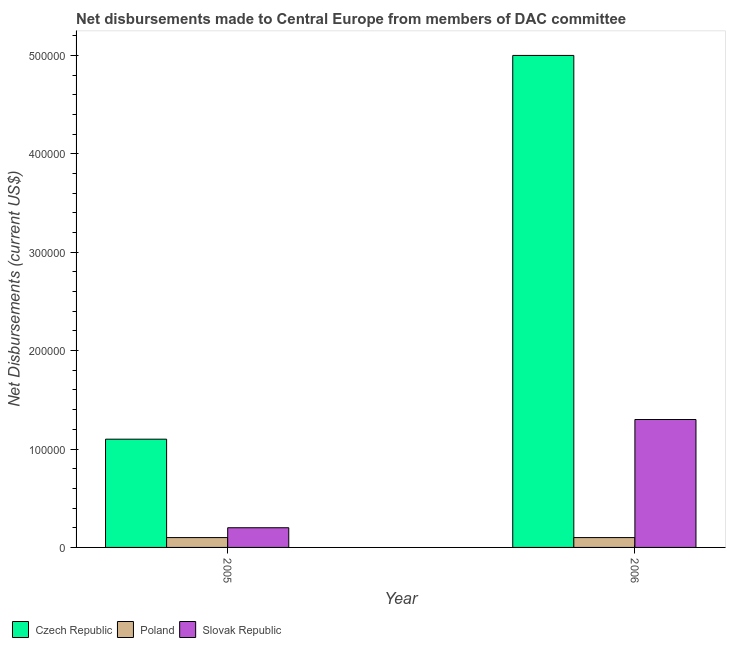How many different coloured bars are there?
Your answer should be compact. 3. How many groups of bars are there?
Provide a succinct answer. 2. How many bars are there on the 1st tick from the right?
Your response must be concise. 3. What is the label of the 2nd group of bars from the left?
Offer a very short reply. 2006. In how many cases, is the number of bars for a given year not equal to the number of legend labels?
Offer a very short reply. 0. What is the net disbursements made by slovak republic in 2005?
Offer a very short reply. 2.00e+04. Across all years, what is the maximum net disbursements made by czech republic?
Provide a succinct answer. 5.00e+05. Across all years, what is the minimum net disbursements made by slovak republic?
Provide a short and direct response. 2.00e+04. In which year was the net disbursements made by slovak republic minimum?
Make the answer very short. 2005. What is the total net disbursements made by poland in the graph?
Make the answer very short. 2.00e+04. What is the difference between the net disbursements made by poland in 2005 and that in 2006?
Provide a succinct answer. 0. What is the difference between the net disbursements made by slovak republic in 2006 and the net disbursements made by czech republic in 2005?
Your response must be concise. 1.10e+05. What is the average net disbursements made by slovak republic per year?
Ensure brevity in your answer.  7.50e+04. In the year 2005, what is the difference between the net disbursements made by poland and net disbursements made by czech republic?
Offer a very short reply. 0. What is the ratio of the net disbursements made by slovak republic in 2005 to that in 2006?
Keep it short and to the point. 0.15. Is the net disbursements made by poland in 2005 less than that in 2006?
Provide a succinct answer. No. What does the 1st bar from the left in 2006 represents?
Provide a short and direct response. Czech Republic. What does the 3rd bar from the right in 2005 represents?
Your answer should be compact. Czech Republic. How many years are there in the graph?
Keep it short and to the point. 2. What is the difference between two consecutive major ticks on the Y-axis?
Give a very brief answer. 1.00e+05. Are the values on the major ticks of Y-axis written in scientific E-notation?
Your answer should be compact. No. Does the graph contain any zero values?
Keep it short and to the point. No. Does the graph contain grids?
Make the answer very short. No. What is the title of the graph?
Keep it short and to the point. Net disbursements made to Central Europe from members of DAC committee. Does "Argument" appear as one of the legend labels in the graph?
Offer a very short reply. No. What is the label or title of the X-axis?
Keep it short and to the point. Year. What is the label or title of the Y-axis?
Your answer should be compact. Net Disbursements (current US$). What is the Net Disbursements (current US$) of Poland in 2005?
Your response must be concise. 10000. What is the Net Disbursements (current US$) in Slovak Republic in 2005?
Your response must be concise. 2.00e+04. What is the Net Disbursements (current US$) in Slovak Republic in 2006?
Offer a very short reply. 1.30e+05. Across all years, what is the maximum Net Disbursements (current US$) of Czech Republic?
Provide a succinct answer. 5.00e+05. Across all years, what is the maximum Net Disbursements (current US$) of Slovak Republic?
Offer a very short reply. 1.30e+05. What is the total Net Disbursements (current US$) in Czech Republic in the graph?
Keep it short and to the point. 6.10e+05. What is the total Net Disbursements (current US$) in Slovak Republic in the graph?
Your answer should be very brief. 1.50e+05. What is the difference between the Net Disbursements (current US$) in Czech Republic in 2005 and that in 2006?
Your response must be concise. -3.90e+05. What is the difference between the Net Disbursements (current US$) in Slovak Republic in 2005 and that in 2006?
Offer a terse response. -1.10e+05. What is the difference between the Net Disbursements (current US$) of Czech Republic in 2005 and the Net Disbursements (current US$) of Poland in 2006?
Give a very brief answer. 1.00e+05. What is the difference between the Net Disbursements (current US$) of Czech Republic in 2005 and the Net Disbursements (current US$) of Slovak Republic in 2006?
Offer a very short reply. -2.00e+04. What is the average Net Disbursements (current US$) in Czech Republic per year?
Your response must be concise. 3.05e+05. What is the average Net Disbursements (current US$) of Poland per year?
Keep it short and to the point. 10000. What is the average Net Disbursements (current US$) of Slovak Republic per year?
Provide a short and direct response. 7.50e+04. In the year 2005, what is the difference between the Net Disbursements (current US$) of Czech Republic and Net Disbursements (current US$) of Poland?
Ensure brevity in your answer.  1.00e+05. In the year 2005, what is the difference between the Net Disbursements (current US$) of Poland and Net Disbursements (current US$) of Slovak Republic?
Your answer should be very brief. -10000. In the year 2006, what is the difference between the Net Disbursements (current US$) of Czech Republic and Net Disbursements (current US$) of Poland?
Ensure brevity in your answer.  4.90e+05. In the year 2006, what is the difference between the Net Disbursements (current US$) of Czech Republic and Net Disbursements (current US$) of Slovak Republic?
Provide a succinct answer. 3.70e+05. What is the ratio of the Net Disbursements (current US$) of Czech Republic in 2005 to that in 2006?
Your answer should be very brief. 0.22. What is the ratio of the Net Disbursements (current US$) of Slovak Republic in 2005 to that in 2006?
Keep it short and to the point. 0.15. What is the difference between the highest and the second highest Net Disbursements (current US$) in Czech Republic?
Your answer should be very brief. 3.90e+05. What is the difference between the highest and the second highest Net Disbursements (current US$) in Poland?
Your answer should be very brief. 0. What is the difference between the highest and the lowest Net Disbursements (current US$) in Czech Republic?
Offer a very short reply. 3.90e+05. What is the difference between the highest and the lowest Net Disbursements (current US$) in Poland?
Keep it short and to the point. 0. What is the difference between the highest and the lowest Net Disbursements (current US$) in Slovak Republic?
Your answer should be compact. 1.10e+05. 